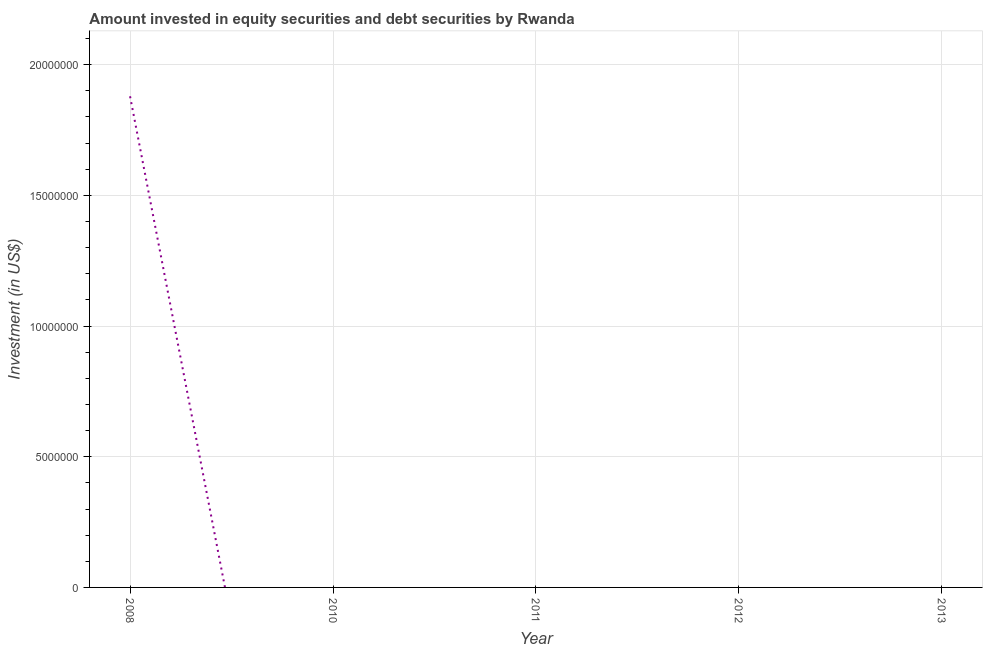Across all years, what is the maximum portfolio investment?
Give a very brief answer. 1.88e+07. In which year was the portfolio investment maximum?
Your answer should be compact. 2008. What is the sum of the portfolio investment?
Provide a short and direct response. 1.88e+07. What is the average portfolio investment per year?
Keep it short and to the point. 3.76e+06. What is the median portfolio investment?
Offer a terse response. 0. What is the difference between the highest and the lowest portfolio investment?
Offer a very short reply. 1.88e+07. How many lines are there?
Keep it short and to the point. 1. What is the title of the graph?
Your answer should be very brief. Amount invested in equity securities and debt securities by Rwanda. What is the label or title of the Y-axis?
Keep it short and to the point. Investment (in US$). What is the Investment (in US$) in 2008?
Ensure brevity in your answer.  1.88e+07. 